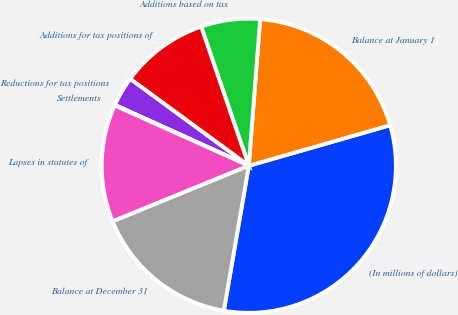Convert chart. <chart><loc_0><loc_0><loc_500><loc_500><pie_chart><fcel>(In millions of dollars)<fcel>Balance at January 1<fcel>Additions based on tax<fcel>Additions for tax positions of<fcel>Reductions for tax positions<fcel>Settlements<fcel>Lapses in statutes of<fcel>Balance at December 31<nl><fcel>32.16%<fcel>19.32%<fcel>6.48%<fcel>9.69%<fcel>3.27%<fcel>0.06%<fcel>12.9%<fcel>16.11%<nl></chart> 